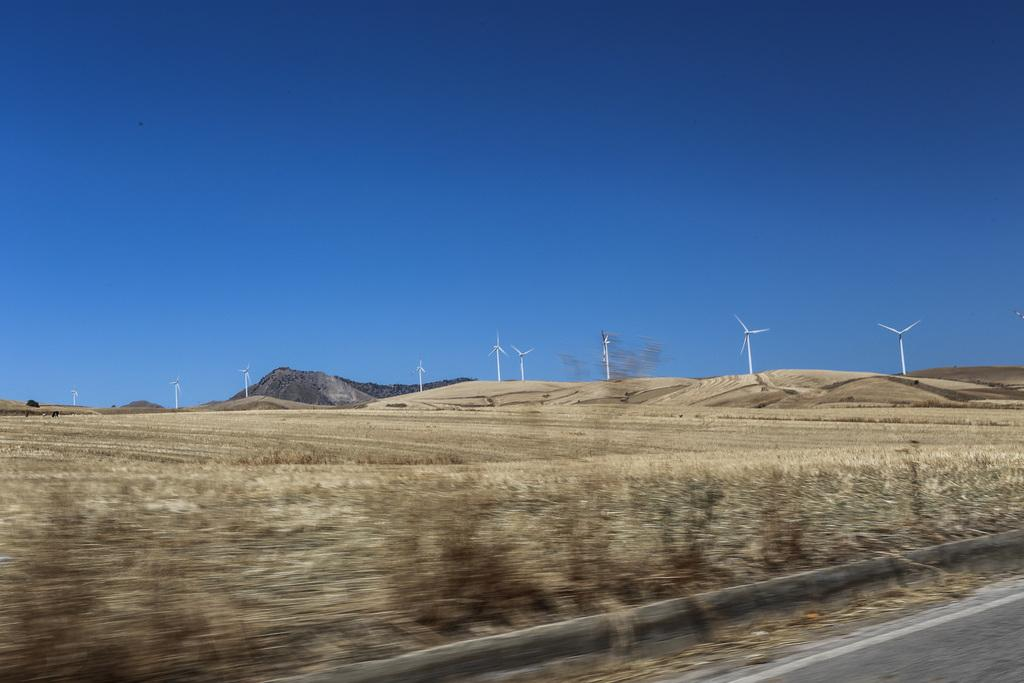What type of terrain is visible at the bottom of the image? There is a grassy land at the bottom of the image. What structures can be seen in the background of the image? There are turbines in the background of the image. What color is the sky in the image? The sky is blue at the top of the image. Can you see any cobwebs hanging from the turbines in the image? There is no mention of cobwebs in the image, and they are not visible in the provided facts. Is there a locket hanging from the grassy land in the image? There is no locket mentioned or visible in the image based on the provided facts. 